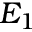Convert formula to latex. <formula><loc_0><loc_0><loc_500><loc_500>E _ { 1 }</formula> 